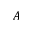<formula> <loc_0><loc_0><loc_500><loc_500>A</formula> 